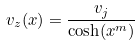Convert formula to latex. <formula><loc_0><loc_0><loc_500><loc_500>v _ { z } ( x ) = \frac { v _ { j } } { \cosh ( x ^ { m } ) }</formula> 